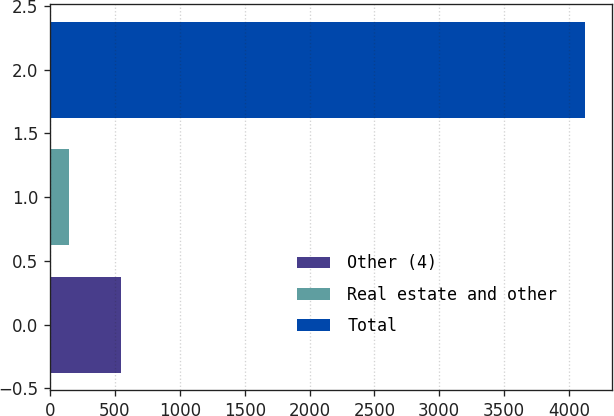<chart> <loc_0><loc_0><loc_500><loc_500><bar_chart><fcel>Other (4)<fcel>Real estate and other<fcel>Total<nl><fcel>545<fcel>147<fcel>4127<nl></chart> 